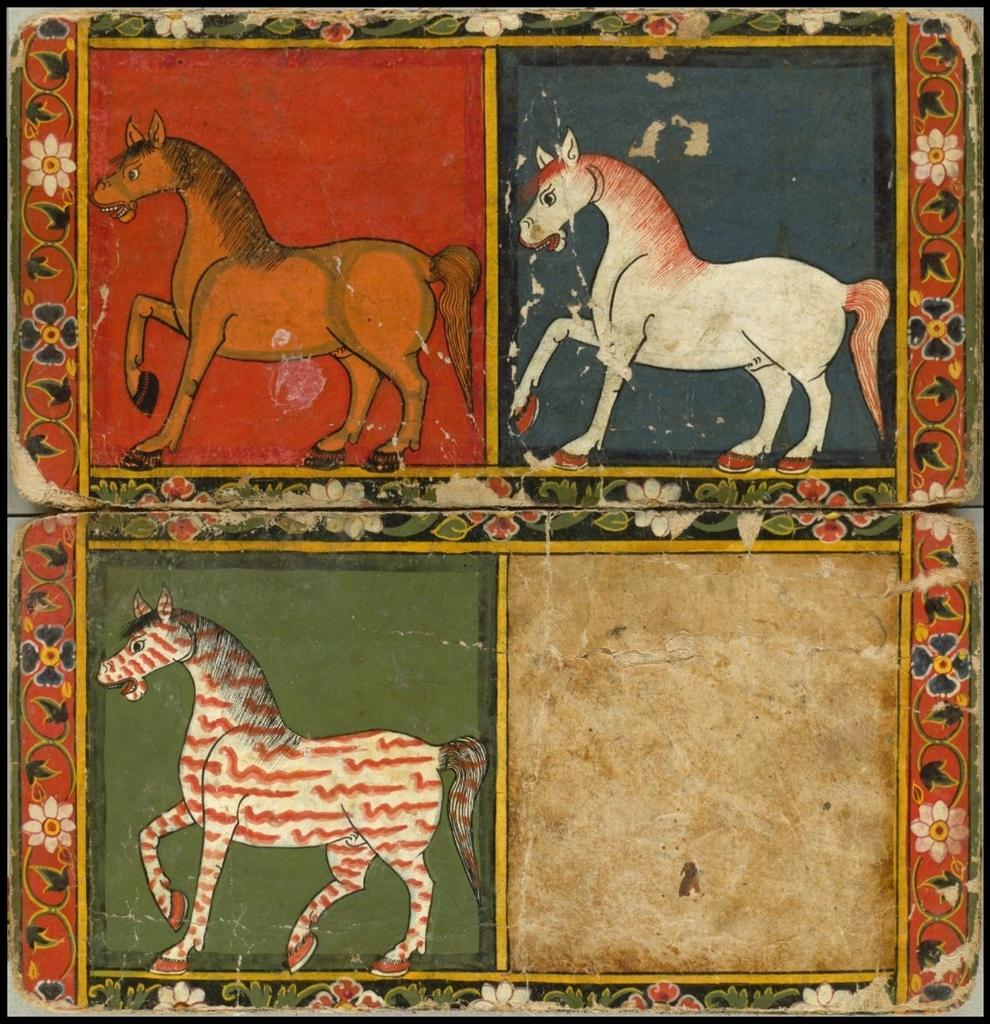What is the main subject of the image? There is a painting in the image. What is the painting placed on? The painting is on a wooden surface. What is depicted in the painting? The painting depicts three horses. What is the name of the person enjoying the snow in the image? There is no person enjoying the snow in the image, as it only features a painting of three horses on a wooden surface. 